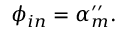Convert formula to latex. <formula><loc_0><loc_0><loc_500><loc_500>\phi _ { i n } = \alpha _ { m } ^ { \prime \prime } .</formula> 